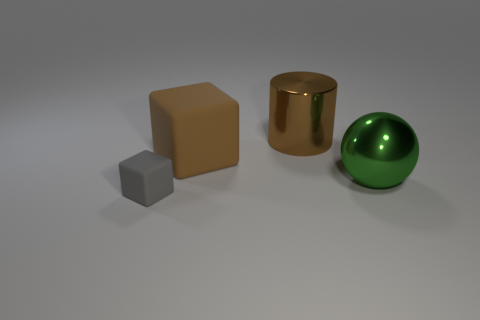How many things are both behind the big green thing and in front of the big cylinder?
Your response must be concise. 1. What material is the brown object that is the same shape as the small gray thing?
Make the answer very short. Rubber. There is a thing that is on the left side of the matte thing that is behind the gray thing; what size is it?
Provide a succinct answer. Small. Are any big red metallic objects visible?
Provide a short and direct response. No. The object that is left of the large shiny sphere and on the right side of the large brown cube is made of what material?
Your answer should be very brief. Metal. Are there more tiny cubes that are in front of the small gray cube than large green objects that are behind the green metal thing?
Give a very brief answer. No. Are there any cubes of the same size as the green thing?
Ensure brevity in your answer.  Yes. There is a thing behind the block right of the object left of the brown rubber cube; what size is it?
Provide a succinct answer. Large. The big matte thing has what color?
Provide a short and direct response. Brown. Are there more tiny gray matte objects that are behind the large brown rubber thing than big metal spheres?
Make the answer very short. No. 